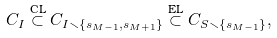<formula> <loc_0><loc_0><loc_500><loc_500>C _ { I } \overset { \text {CL} } { \subset } C _ { I \smallsetminus \{ s _ { M - 1 } , s _ { M + 1 } \} } \overset { \text {EL} } { \subset } C _ { S \smallsetminus \{ s _ { M - 1 } \} } ,</formula> 